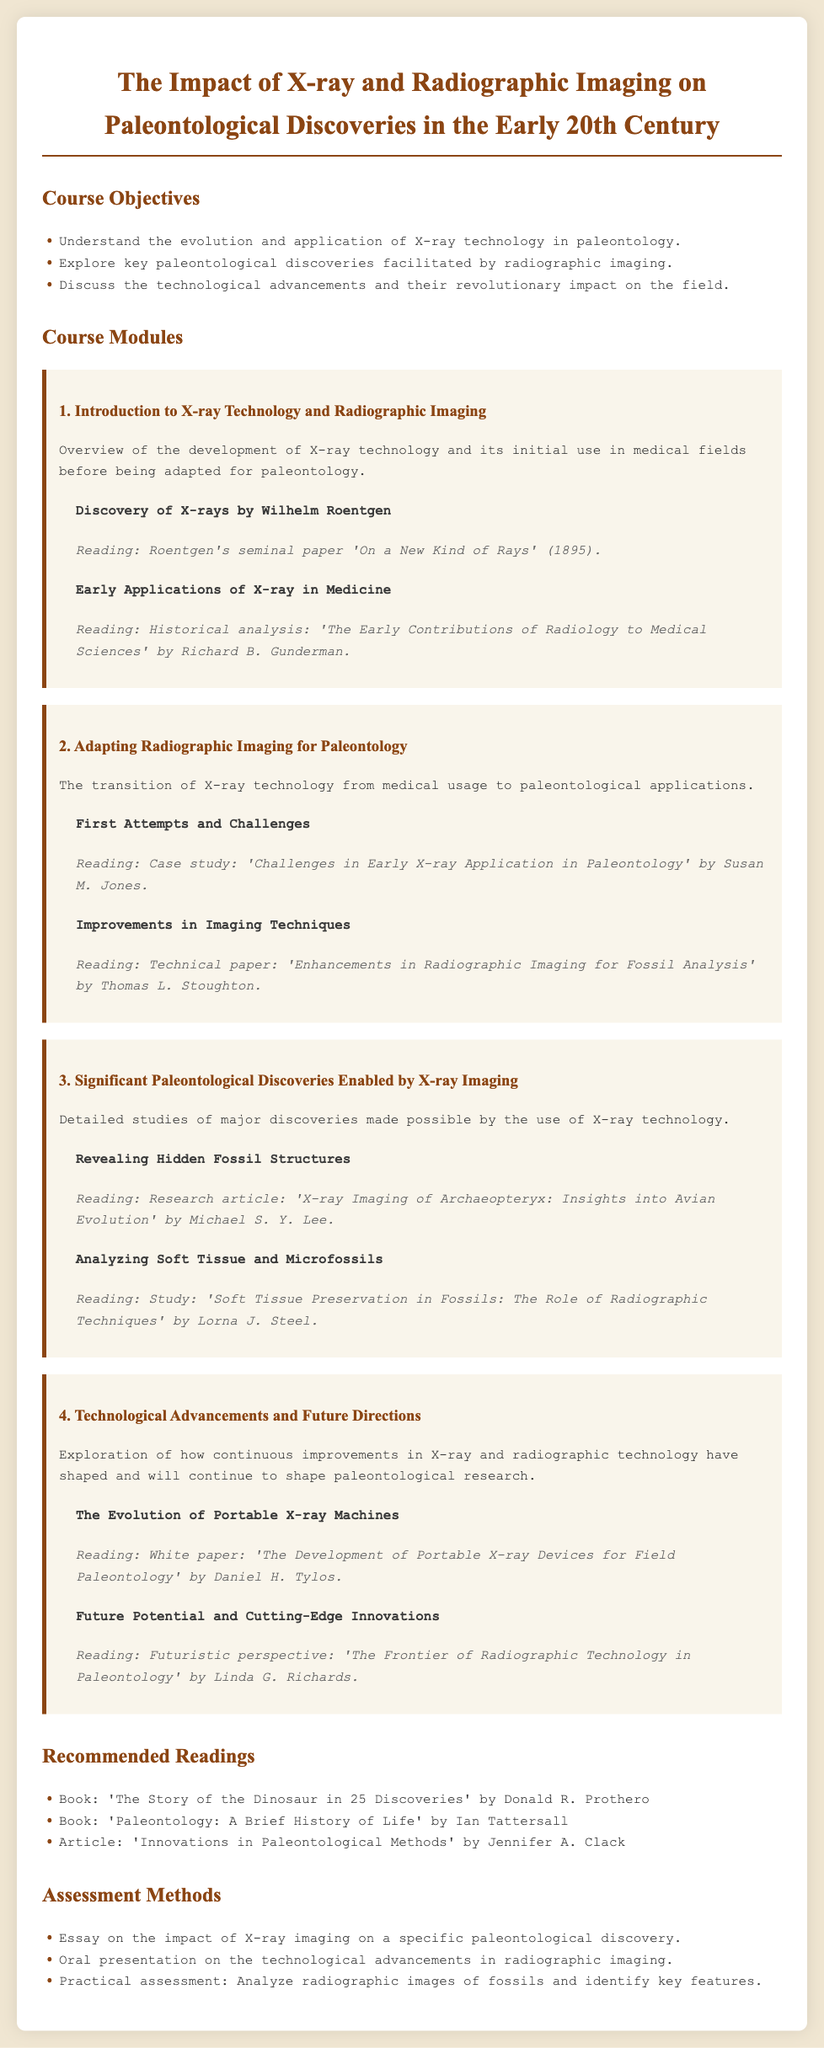What is the title of the syllabus? The title provided in the document gives a clear indication of the subject matter.
Answer: The Impact of X-ray and Radiographic Imaging on Paleontological Discoveries in the Early 20th Century Who discovered X-rays? The syllabus mentions Wilhelm Roentgen as the person who discovered X-rays.
Answer: Wilhelm Roentgen What is the focus of Module 2? The description of Module 2 explicitly states its main topic.
Answer: Adapting Radiographic Imaging for Paleontology Which reading discusses improvements in imaging techniques? The syllabus lists specific readings under each module, including one for improvements.
Answer: Enhancements in Radiographic Imaging for Fossil Analysis What is one of the assessment methods mentioned? The document outlines specific ways students will be evaluated.
Answer: Essay on the impact of X-ray imaging on a specific paleontological discovery In which reading can one find information about soft tissue preservation in fossils? The details of various readings in the syllabus pinpoint this specific research article.
Answer: Soft Tissue Preservation in Fossils: The Role of Radiographic Techniques How many modules are included in the course? The total number of distinct sections devoted to different topics can be counted from the syllabus structure.
Answer: 4 What type of advancements are discussed in the last module? The syllabus describes the content of the last module and its themes.
Answer: Technological Advancements and Future Directions 